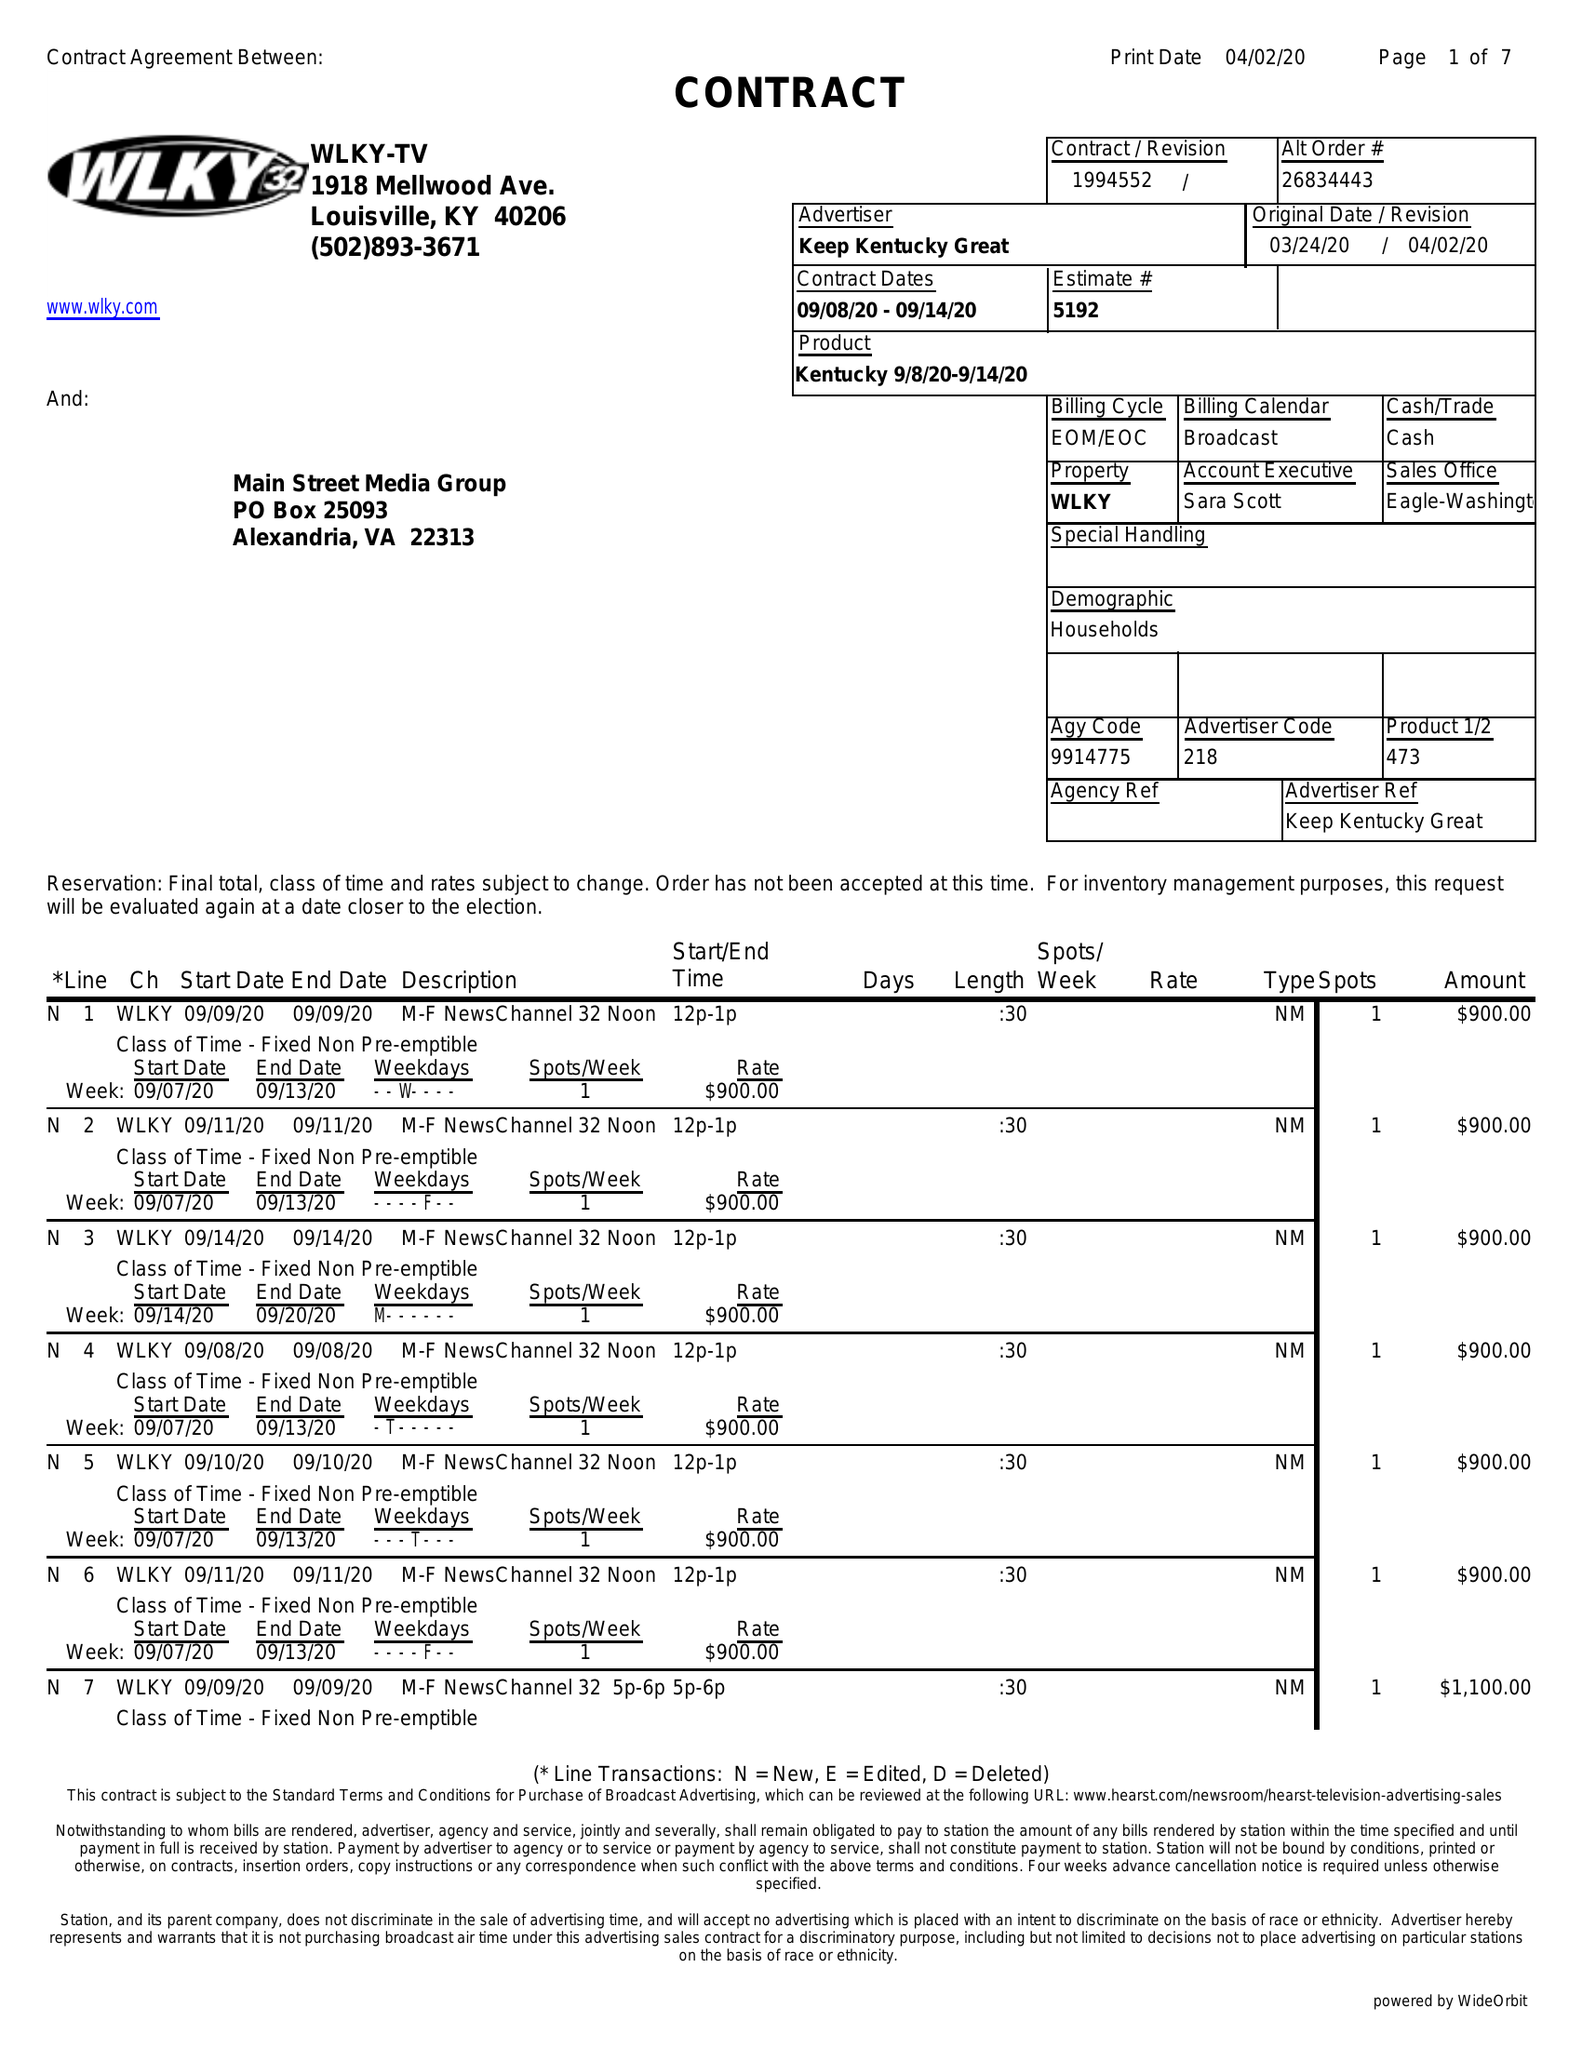What is the value for the contract_num?
Answer the question using a single word or phrase. 1994552 